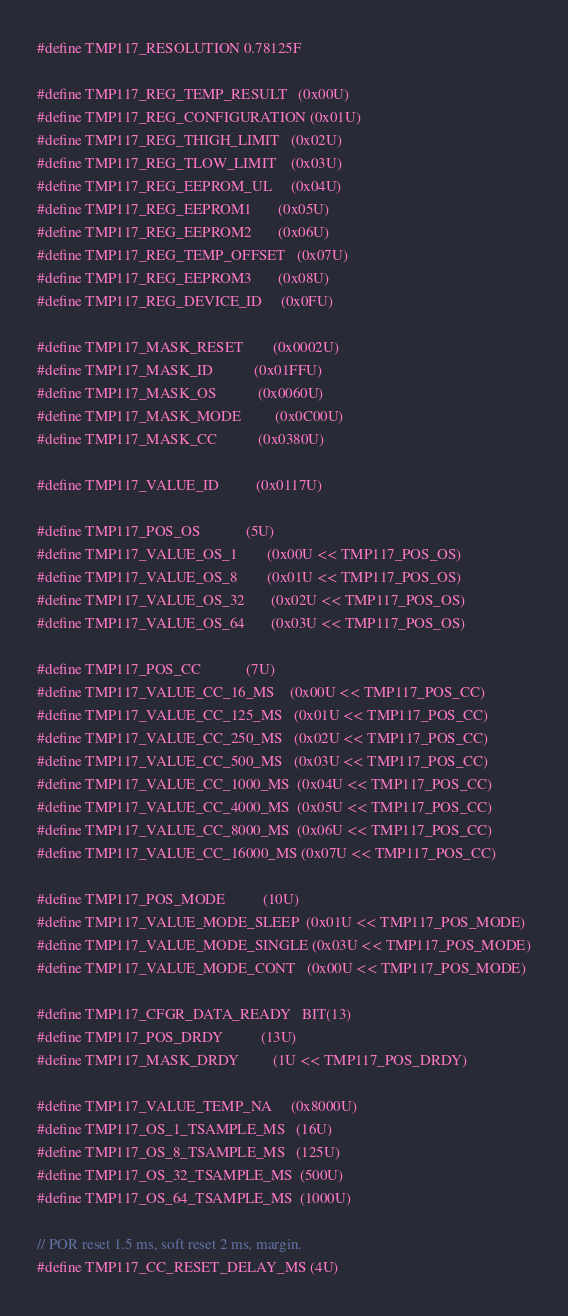<code> <loc_0><loc_0><loc_500><loc_500><_C_>#define TMP117_RESOLUTION 0.78125F

#define TMP117_REG_TEMP_RESULT   (0x00U)
#define TMP117_REG_CONFIGURATION (0x01U)
#define TMP117_REG_THIGH_LIMIT   (0x02U)
#define TMP117_REG_TLOW_LIMIT    (0x03U)
#define TMP117_REG_EEPROM_UL     (0x04U)
#define TMP117_REG_EEPROM1       (0x05U)
#define TMP117_REG_EEPROM2       (0x06U)
#define TMP117_REG_TEMP_OFFSET   (0x07U)
#define TMP117_REG_EEPROM3       (0x08U)
#define TMP117_REG_DEVICE_ID     (0x0FU)

#define TMP117_MASK_RESET        (0x0002U)
#define TMP117_MASK_ID           (0x01FFU)
#define TMP117_MASK_OS           (0x0060U)
#define TMP117_MASK_MODE         (0x0C00U)
#define TMP117_MASK_CC           (0x0380U)

#define TMP117_VALUE_ID          (0x0117U)

#define TMP117_POS_OS            (5U)
#define TMP117_VALUE_OS_1        (0x00U << TMP117_POS_OS)
#define TMP117_VALUE_OS_8        (0x01U << TMP117_POS_OS)
#define TMP117_VALUE_OS_32       (0x02U << TMP117_POS_OS)
#define TMP117_VALUE_OS_64       (0x03U << TMP117_POS_OS)

#define TMP117_POS_CC            (7U)
#define TMP117_VALUE_CC_16_MS    (0x00U << TMP117_POS_CC)
#define TMP117_VALUE_CC_125_MS   (0x01U << TMP117_POS_CC)
#define TMP117_VALUE_CC_250_MS   (0x02U << TMP117_POS_CC)
#define TMP117_VALUE_CC_500_MS   (0x03U << TMP117_POS_CC)
#define TMP117_VALUE_CC_1000_MS  (0x04U << TMP117_POS_CC)
#define TMP117_VALUE_CC_4000_MS  (0x05U << TMP117_POS_CC)
#define TMP117_VALUE_CC_8000_MS  (0x06U << TMP117_POS_CC)
#define TMP117_VALUE_CC_16000_MS (0x07U << TMP117_POS_CC)

#define TMP117_POS_MODE          (10U)
#define TMP117_VALUE_MODE_SLEEP  (0x01U << TMP117_POS_MODE)
#define TMP117_VALUE_MODE_SINGLE (0x03U << TMP117_POS_MODE)
#define TMP117_VALUE_MODE_CONT   (0x00U << TMP117_POS_MODE)

#define TMP117_CFGR_DATA_READY   BIT(13)
#define TMP117_POS_DRDY          (13U)
#define TMP117_MASK_DRDY         (1U << TMP117_POS_DRDY)

#define TMP117_VALUE_TEMP_NA     (0x8000U)
#define TMP117_OS_1_TSAMPLE_MS   (16U)
#define TMP117_OS_8_TSAMPLE_MS   (125U)
#define TMP117_OS_32_TSAMPLE_MS  (500U)
#define TMP117_OS_64_TSAMPLE_MS  (1000U)

// POR reset 1.5 ms, soft reset 2 ms, margin.
#define TMP117_CC_RESET_DELAY_MS (4U)</code> 